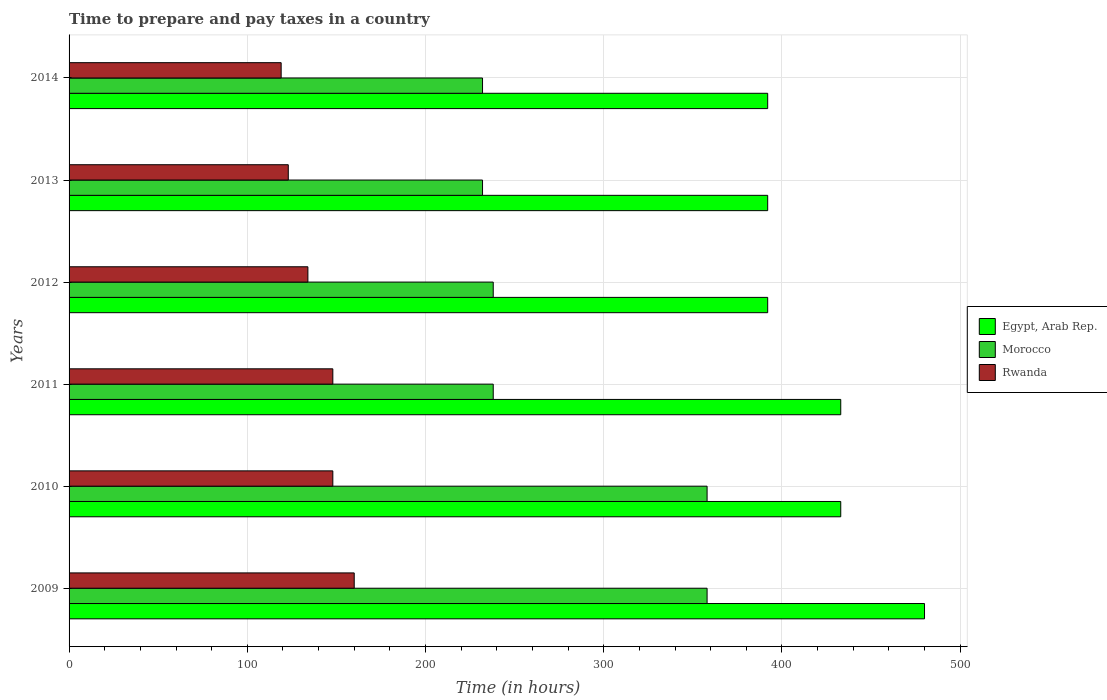How many different coloured bars are there?
Ensure brevity in your answer.  3. How many groups of bars are there?
Ensure brevity in your answer.  6. Are the number of bars per tick equal to the number of legend labels?
Your answer should be compact. Yes. How many bars are there on the 6th tick from the top?
Your answer should be compact. 3. How many bars are there on the 5th tick from the bottom?
Make the answer very short. 3. In how many cases, is the number of bars for a given year not equal to the number of legend labels?
Provide a succinct answer. 0. What is the number of hours required to prepare and pay taxes in Morocco in 2009?
Your response must be concise. 358. Across all years, what is the maximum number of hours required to prepare and pay taxes in Morocco?
Ensure brevity in your answer.  358. Across all years, what is the minimum number of hours required to prepare and pay taxes in Rwanda?
Offer a very short reply. 119. In which year was the number of hours required to prepare and pay taxes in Egypt, Arab Rep. maximum?
Your response must be concise. 2009. In which year was the number of hours required to prepare and pay taxes in Rwanda minimum?
Your answer should be compact. 2014. What is the total number of hours required to prepare and pay taxes in Rwanda in the graph?
Ensure brevity in your answer.  832. What is the difference between the number of hours required to prepare and pay taxes in Morocco in 2009 and that in 2013?
Provide a short and direct response. 126. What is the difference between the number of hours required to prepare and pay taxes in Morocco in 2009 and the number of hours required to prepare and pay taxes in Egypt, Arab Rep. in 2014?
Make the answer very short. -34. What is the average number of hours required to prepare and pay taxes in Morocco per year?
Your response must be concise. 276. In the year 2013, what is the difference between the number of hours required to prepare and pay taxes in Egypt, Arab Rep. and number of hours required to prepare and pay taxes in Rwanda?
Offer a terse response. 269. What is the ratio of the number of hours required to prepare and pay taxes in Egypt, Arab Rep. in 2011 to that in 2014?
Ensure brevity in your answer.  1.1. Is the number of hours required to prepare and pay taxes in Rwanda in 2013 less than that in 2014?
Ensure brevity in your answer.  No. Is the difference between the number of hours required to prepare and pay taxes in Egypt, Arab Rep. in 2009 and 2013 greater than the difference between the number of hours required to prepare and pay taxes in Rwanda in 2009 and 2013?
Make the answer very short. Yes. What is the difference between the highest and the lowest number of hours required to prepare and pay taxes in Egypt, Arab Rep.?
Your answer should be very brief. 88. What does the 2nd bar from the top in 2011 represents?
Your answer should be compact. Morocco. What does the 2nd bar from the bottom in 2011 represents?
Keep it short and to the point. Morocco. How many years are there in the graph?
Ensure brevity in your answer.  6. What is the difference between two consecutive major ticks on the X-axis?
Keep it short and to the point. 100. Are the values on the major ticks of X-axis written in scientific E-notation?
Give a very brief answer. No. Does the graph contain any zero values?
Your answer should be compact. No. Does the graph contain grids?
Provide a succinct answer. Yes. How are the legend labels stacked?
Ensure brevity in your answer.  Vertical. What is the title of the graph?
Provide a short and direct response. Time to prepare and pay taxes in a country. Does "Macedonia" appear as one of the legend labels in the graph?
Ensure brevity in your answer.  No. What is the label or title of the X-axis?
Keep it short and to the point. Time (in hours). What is the Time (in hours) of Egypt, Arab Rep. in 2009?
Provide a succinct answer. 480. What is the Time (in hours) in Morocco in 2009?
Your answer should be very brief. 358. What is the Time (in hours) of Rwanda in 2009?
Your answer should be compact. 160. What is the Time (in hours) in Egypt, Arab Rep. in 2010?
Provide a short and direct response. 433. What is the Time (in hours) of Morocco in 2010?
Your answer should be very brief. 358. What is the Time (in hours) of Rwanda in 2010?
Offer a very short reply. 148. What is the Time (in hours) in Egypt, Arab Rep. in 2011?
Your answer should be compact. 433. What is the Time (in hours) in Morocco in 2011?
Your response must be concise. 238. What is the Time (in hours) of Rwanda in 2011?
Give a very brief answer. 148. What is the Time (in hours) of Egypt, Arab Rep. in 2012?
Provide a succinct answer. 392. What is the Time (in hours) of Morocco in 2012?
Your answer should be very brief. 238. What is the Time (in hours) of Rwanda in 2012?
Provide a succinct answer. 134. What is the Time (in hours) in Egypt, Arab Rep. in 2013?
Your response must be concise. 392. What is the Time (in hours) of Morocco in 2013?
Provide a short and direct response. 232. What is the Time (in hours) in Rwanda in 2013?
Keep it short and to the point. 123. What is the Time (in hours) in Egypt, Arab Rep. in 2014?
Give a very brief answer. 392. What is the Time (in hours) of Morocco in 2014?
Your response must be concise. 232. What is the Time (in hours) in Rwanda in 2014?
Ensure brevity in your answer.  119. Across all years, what is the maximum Time (in hours) in Egypt, Arab Rep.?
Offer a terse response. 480. Across all years, what is the maximum Time (in hours) of Morocco?
Provide a succinct answer. 358. Across all years, what is the maximum Time (in hours) in Rwanda?
Provide a short and direct response. 160. Across all years, what is the minimum Time (in hours) in Egypt, Arab Rep.?
Offer a very short reply. 392. Across all years, what is the minimum Time (in hours) of Morocco?
Make the answer very short. 232. Across all years, what is the minimum Time (in hours) in Rwanda?
Make the answer very short. 119. What is the total Time (in hours) of Egypt, Arab Rep. in the graph?
Provide a succinct answer. 2522. What is the total Time (in hours) of Morocco in the graph?
Provide a succinct answer. 1656. What is the total Time (in hours) in Rwanda in the graph?
Ensure brevity in your answer.  832. What is the difference between the Time (in hours) of Egypt, Arab Rep. in 2009 and that in 2010?
Provide a short and direct response. 47. What is the difference between the Time (in hours) in Morocco in 2009 and that in 2010?
Your answer should be compact. 0. What is the difference between the Time (in hours) of Morocco in 2009 and that in 2011?
Provide a succinct answer. 120. What is the difference between the Time (in hours) in Rwanda in 2009 and that in 2011?
Your response must be concise. 12. What is the difference between the Time (in hours) in Egypt, Arab Rep. in 2009 and that in 2012?
Offer a very short reply. 88. What is the difference between the Time (in hours) in Morocco in 2009 and that in 2012?
Offer a terse response. 120. What is the difference between the Time (in hours) of Rwanda in 2009 and that in 2012?
Your answer should be compact. 26. What is the difference between the Time (in hours) of Egypt, Arab Rep. in 2009 and that in 2013?
Offer a terse response. 88. What is the difference between the Time (in hours) in Morocco in 2009 and that in 2013?
Your response must be concise. 126. What is the difference between the Time (in hours) in Rwanda in 2009 and that in 2013?
Offer a terse response. 37. What is the difference between the Time (in hours) in Egypt, Arab Rep. in 2009 and that in 2014?
Your answer should be very brief. 88. What is the difference between the Time (in hours) in Morocco in 2009 and that in 2014?
Make the answer very short. 126. What is the difference between the Time (in hours) of Rwanda in 2009 and that in 2014?
Your response must be concise. 41. What is the difference between the Time (in hours) in Morocco in 2010 and that in 2011?
Provide a succinct answer. 120. What is the difference between the Time (in hours) in Rwanda in 2010 and that in 2011?
Give a very brief answer. 0. What is the difference between the Time (in hours) of Egypt, Arab Rep. in 2010 and that in 2012?
Make the answer very short. 41. What is the difference between the Time (in hours) of Morocco in 2010 and that in 2012?
Give a very brief answer. 120. What is the difference between the Time (in hours) of Rwanda in 2010 and that in 2012?
Give a very brief answer. 14. What is the difference between the Time (in hours) in Egypt, Arab Rep. in 2010 and that in 2013?
Ensure brevity in your answer.  41. What is the difference between the Time (in hours) in Morocco in 2010 and that in 2013?
Your answer should be compact. 126. What is the difference between the Time (in hours) in Egypt, Arab Rep. in 2010 and that in 2014?
Your response must be concise. 41. What is the difference between the Time (in hours) of Morocco in 2010 and that in 2014?
Ensure brevity in your answer.  126. What is the difference between the Time (in hours) in Morocco in 2011 and that in 2012?
Provide a succinct answer. 0. What is the difference between the Time (in hours) in Egypt, Arab Rep. in 2011 and that in 2013?
Provide a short and direct response. 41. What is the difference between the Time (in hours) in Rwanda in 2011 and that in 2013?
Keep it short and to the point. 25. What is the difference between the Time (in hours) in Egypt, Arab Rep. in 2011 and that in 2014?
Offer a terse response. 41. What is the difference between the Time (in hours) in Egypt, Arab Rep. in 2012 and that in 2013?
Provide a short and direct response. 0. What is the difference between the Time (in hours) in Rwanda in 2012 and that in 2013?
Your answer should be very brief. 11. What is the difference between the Time (in hours) in Morocco in 2012 and that in 2014?
Ensure brevity in your answer.  6. What is the difference between the Time (in hours) of Rwanda in 2012 and that in 2014?
Ensure brevity in your answer.  15. What is the difference between the Time (in hours) of Morocco in 2013 and that in 2014?
Offer a very short reply. 0. What is the difference between the Time (in hours) in Rwanda in 2013 and that in 2014?
Give a very brief answer. 4. What is the difference between the Time (in hours) of Egypt, Arab Rep. in 2009 and the Time (in hours) of Morocco in 2010?
Offer a terse response. 122. What is the difference between the Time (in hours) of Egypt, Arab Rep. in 2009 and the Time (in hours) of Rwanda in 2010?
Your answer should be very brief. 332. What is the difference between the Time (in hours) of Morocco in 2009 and the Time (in hours) of Rwanda in 2010?
Keep it short and to the point. 210. What is the difference between the Time (in hours) in Egypt, Arab Rep. in 2009 and the Time (in hours) in Morocco in 2011?
Keep it short and to the point. 242. What is the difference between the Time (in hours) in Egypt, Arab Rep. in 2009 and the Time (in hours) in Rwanda in 2011?
Ensure brevity in your answer.  332. What is the difference between the Time (in hours) of Morocco in 2009 and the Time (in hours) of Rwanda in 2011?
Make the answer very short. 210. What is the difference between the Time (in hours) of Egypt, Arab Rep. in 2009 and the Time (in hours) of Morocco in 2012?
Offer a very short reply. 242. What is the difference between the Time (in hours) in Egypt, Arab Rep. in 2009 and the Time (in hours) in Rwanda in 2012?
Provide a succinct answer. 346. What is the difference between the Time (in hours) of Morocco in 2009 and the Time (in hours) of Rwanda in 2012?
Keep it short and to the point. 224. What is the difference between the Time (in hours) in Egypt, Arab Rep. in 2009 and the Time (in hours) in Morocco in 2013?
Ensure brevity in your answer.  248. What is the difference between the Time (in hours) in Egypt, Arab Rep. in 2009 and the Time (in hours) in Rwanda in 2013?
Your answer should be very brief. 357. What is the difference between the Time (in hours) of Morocco in 2009 and the Time (in hours) of Rwanda in 2013?
Ensure brevity in your answer.  235. What is the difference between the Time (in hours) in Egypt, Arab Rep. in 2009 and the Time (in hours) in Morocco in 2014?
Ensure brevity in your answer.  248. What is the difference between the Time (in hours) in Egypt, Arab Rep. in 2009 and the Time (in hours) in Rwanda in 2014?
Your response must be concise. 361. What is the difference between the Time (in hours) in Morocco in 2009 and the Time (in hours) in Rwanda in 2014?
Keep it short and to the point. 239. What is the difference between the Time (in hours) in Egypt, Arab Rep. in 2010 and the Time (in hours) in Morocco in 2011?
Offer a terse response. 195. What is the difference between the Time (in hours) in Egypt, Arab Rep. in 2010 and the Time (in hours) in Rwanda in 2011?
Your response must be concise. 285. What is the difference between the Time (in hours) in Morocco in 2010 and the Time (in hours) in Rwanda in 2011?
Your answer should be very brief. 210. What is the difference between the Time (in hours) of Egypt, Arab Rep. in 2010 and the Time (in hours) of Morocco in 2012?
Keep it short and to the point. 195. What is the difference between the Time (in hours) of Egypt, Arab Rep. in 2010 and the Time (in hours) of Rwanda in 2012?
Keep it short and to the point. 299. What is the difference between the Time (in hours) in Morocco in 2010 and the Time (in hours) in Rwanda in 2012?
Give a very brief answer. 224. What is the difference between the Time (in hours) of Egypt, Arab Rep. in 2010 and the Time (in hours) of Morocco in 2013?
Your response must be concise. 201. What is the difference between the Time (in hours) of Egypt, Arab Rep. in 2010 and the Time (in hours) of Rwanda in 2013?
Offer a very short reply. 310. What is the difference between the Time (in hours) in Morocco in 2010 and the Time (in hours) in Rwanda in 2013?
Provide a short and direct response. 235. What is the difference between the Time (in hours) in Egypt, Arab Rep. in 2010 and the Time (in hours) in Morocco in 2014?
Your response must be concise. 201. What is the difference between the Time (in hours) of Egypt, Arab Rep. in 2010 and the Time (in hours) of Rwanda in 2014?
Make the answer very short. 314. What is the difference between the Time (in hours) of Morocco in 2010 and the Time (in hours) of Rwanda in 2014?
Ensure brevity in your answer.  239. What is the difference between the Time (in hours) of Egypt, Arab Rep. in 2011 and the Time (in hours) of Morocco in 2012?
Your answer should be very brief. 195. What is the difference between the Time (in hours) of Egypt, Arab Rep. in 2011 and the Time (in hours) of Rwanda in 2012?
Offer a very short reply. 299. What is the difference between the Time (in hours) in Morocco in 2011 and the Time (in hours) in Rwanda in 2012?
Provide a succinct answer. 104. What is the difference between the Time (in hours) of Egypt, Arab Rep. in 2011 and the Time (in hours) of Morocco in 2013?
Provide a succinct answer. 201. What is the difference between the Time (in hours) in Egypt, Arab Rep. in 2011 and the Time (in hours) in Rwanda in 2013?
Offer a terse response. 310. What is the difference between the Time (in hours) of Morocco in 2011 and the Time (in hours) of Rwanda in 2013?
Keep it short and to the point. 115. What is the difference between the Time (in hours) in Egypt, Arab Rep. in 2011 and the Time (in hours) in Morocco in 2014?
Make the answer very short. 201. What is the difference between the Time (in hours) in Egypt, Arab Rep. in 2011 and the Time (in hours) in Rwanda in 2014?
Your answer should be very brief. 314. What is the difference between the Time (in hours) of Morocco in 2011 and the Time (in hours) of Rwanda in 2014?
Your answer should be very brief. 119. What is the difference between the Time (in hours) in Egypt, Arab Rep. in 2012 and the Time (in hours) in Morocco in 2013?
Offer a very short reply. 160. What is the difference between the Time (in hours) in Egypt, Arab Rep. in 2012 and the Time (in hours) in Rwanda in 2013?
Make the answer very short. 269. What is the difference between the Time (in hours) in Morocco in 2012 and the Time (in hours) in Rwanda in 2013?
Ensure brevity in your answer.  115. What is the difference between the Time (in hours) in Egypt, Arab Rep. in 2012 and the Time (in hours) in Morocco in 2014?
Ensure brevity in your answer.  160. What is the difference between the Time (in hours) in Egypt, Arab Rep. in 2012 and the Time (in hours) in Rwanda in 2014?
Provide a succinct answer. 273. What is the difference between the Time (in hours) of Morocco in 2012 and the Time (in hours) of Rwanda in 2014?
Offer a very short reply. 119. What is the difference between the Time (in hours) of Egypt, Arab Rep. in 2013 and the Time (in hours) of Morocco in 2014?
Your answer should be very brief. 160. What is the difference between the Time (in hours) in Egypt, Arab Rep. in 2013 and the Time (in hours) in Rwanda in 2014?
Offer a terse response. 273. What is the difference between the Time (in hours) of Morocco in 2013 and the Time (in hours) of Rwanda in 2014?
Offer a very short reply. 113. What is the average Time (in hours) of Egypt, Arab Rep. per year?
Offer a very short reply. 420.33. What is the average Time (in hours) of Morocco per year?
Give a very brief answer. 276. What is the average Time (in hours) of Rwanda per year?
Make the answer very short. 138.67. In the year 2009, what is the difference between the Time (in hours) of Egypt, Arab Rep. and Time (in hours) of Morocco?
Your answer should be compact. 122. In the year 2009, what is the difference between the Time (in hours) of Egypt, Arab Rep. and Time (in hours) of Rwanda?
Your answer should be compact. 320. In the year 2009, what is the difference between the Time (in hours) of Morocco and Time (in hours) of Rwanda?
Provide a succinct answer. 198. In the year 2010, what is the difference between the Time (in hours) of Egypt, Arab Rep. and Time (in hours) of Rwanda?
Give a very brief answer. 285. In the year 2010, what is the difference between the Time (in hours) in Morocco and Time (in hours) in Rwanda?
Make the answer very short. 210. In the year 2011, what is the difference between the Time (in hours) in Egypt, Arab Rep. and Time (in hours) in Morocco?
Your answer should be compact. 195. In the year 2011, what is the difference between the Time (in hours) in Egypt, Arab Rep. and Time (in hours) in Rwanda?
Your answer should be compact. 285. In the year 2011, what is the difference between the Time (in hours) of Morocco and Time (in hours) of Rwanda?
Give a very brief answer. 90. In the year 2012, what is the difference between the Time (in hours) in Egypt, Arab Rep. and Time (in hours) in Morocco?
Offer a very short reply. 154. In the year 2012, what is the difference between the Time (in hours) of Egypt, Arab Rep. and Time (in hours) of Rwanda?
Offer a very short reply. 258. In the year 2012, what is the difference between the Time (in hours) of Morocco and Time (in hours) of Rwanda?
Give a very brief answer. 104. In the year 2013, what is the difference between the Time (in hours) in Egypt, Arab Rep. and Time (in hours) in Morocco?
Your response must be concise. 160. In the year 2013, what is the difference between the Time (in hours) of Egypt, Arab Rep. and Time (in hours) of Rwanda?
Make the answer very short. 269. In the year 2013, what is the difference between the Time (in hours) in Morocco and Time (in hours) in Rwanda?
Make the answer very short. 109. In the year 2014, what is the difference between the Time (in hours) in Egypt, Arab Rep. and Time (in hours) in Morocco?
Provide a succinct answer. 160. In the year 2014, what is the difference between the Time (in hours) in Egypt, Arab Rep. and Time (in hours) in Rwanda?
Your answer should be compact. 273. In the year 2014, what is the difference between the Time (in hours) in Morocco and Time (in hours) in Rwanda?
Offer a terse response. 113. What is the ratio of the Time (in hours) of Egypt, Arab Rep. in 2009 to that in 2010?
Your answer should be very brief. 1.11. What is the ratio of the Time (in hours) of Morocco in 2009 to that in 2010?
Give a very brief answer. 1. What is the ratio of the Time (in hours) in Rwanda in 2009 to that in 2010?
Your answer should be very brief. 1.08. What is the ratio of the Time (in hours) in Egypt, Arab Rep. in 2009 to that in 2011?
Your answer should be compact. 1.11. What is the ratio of the Time (in hours) of Morocco in 2009 to that in 2011?
Keep it short and to the point. 1.5. What is the ratio of the Time (in hours) in Rwanda in 2009 to that in 2011?
Make the answer very short. 1.08. What is the ratio of the Time (in hours) of Egypt, Arab Rep. in 2009 to that in 2012?
Your answer should be very brief. 1.22. What is the ratio of the Time (in hours) in Morocco in 2009 to that in 2012?
Offer a very short reply. 1.5. What is the ratio of the Time (in hours) of Rwanda in 2009 to that in 2012?
Your answer should be compact. 1.19. What is the ratio of the Time (in hours) of Egypt, Arab Rep. in 2009 to that in 2013?
Your response must be concise. 1.22. What is the ratio of the Time (in hours) of Morocco in 2009 to that in 2013?
Provide a succinct answer. 1.54. What is the ratio of the Time (in hours) in Rwanda in 2009 to that in 2013?
Your answer should be compact. 1.3. What is the ratio of the Time (in hours) in Egypt, Arab Rep. in 2009 to that in 2014?
Offer a terse response. 1.22. What is the ratio of the Time (in hours) in Morocco in 2009 to that in 2014?
Keep it short and to the point. 1.54. What is the ratio of the Time (in hours) of Rwanda in 2009 to that in 2014?
Give a very brief answer. 1.34. What is the ratio of the Time (in hours) in Egypt, Arab Rep. in 2010 to that in 2011?
Provide a succinct answer. 1. What is the ratio of the Time (in hours) of Morocco in 2010 to that in 2011?
Your answer should be compact. 1.5. What is the ratio of the Time (in hours) in Rwanda in 2010 to that in 2011?
Offer a terse response. 1. What is the ratio of the Time (in hours) of Egypt, Arab Rep. in 2010 to that in 2012?
Your response must be concise. 1.1. What is the ratio of the Time (in hours) in Morocco in 2010 to that in 2012?
Make the answer very short. 1.5. What is the ratio of the Time (in hours) in Rwanda in 2010 to that in 2012?
Your response must be concise. 1.1. What is the ratio of the Time (in hours) in Egypt, Arab Rep. in 2010 to that in 2013?
Provide a short and direct response. 1.1. What is the ratio of the Time (in hours) in Morocco in 2010 to that in 2013?
Give a very brief answer. 1.54. What is the ratio of the Time (in hours) in Rwanda in 2010 to that in 2013?
Provide a short and direct response. 1.2. What is the ratio of the Time (in hours) of Egypt, Arab Rep. in 2010 to that in 2014?
Offer a very short reply. 1.1. What is the ratio of the Time (in hours) in Morocco in 2010 to that in 2014?
Provide a short and direct response. 1.54. What is the ratio of the Time (in hours) in Rwanda in 2010 to that in 2014?
Keep it short and to the point. 1.24. What is the ratio of the Time (in hours) in Egypt, Arab Rep. in 2011 to that in 2012?
Provide a short and direct response. 1.1. What is the ratio of the Time (in hours) in Rwanda in 2011 to that in 2012?
Your answer should be compact. 1.1. What is the ratio of the Time (in hours) of Egypt, Arab Rep. in 2011 to that in 2013?
Give a very brief answer. 1.1. What is the ratio of the Time (in hours) in Morocco in 2011 to that in 2013?
Offer a terse response. 1.03. What is the ratio of the Time (in hours) of Rwanda in 2011 to that in 2013?
Provide a succinct answer. 1.2. What is the ratio of the Time (in hours) in Egypt, Arab Rep. in 2011 to that in 2014?
Provide a succinct answer. 1.1. What is the ratio of the Time (in hours) in Morocco in 2011 to that in 2014?
Give a very brief answer. 1.03. What is the ratio of the Time (in hours) in Rwanda in 2011 to that in 2014?
Provide a succinct answer. 1.24. What is the ratio of the Time (in hours) in Egypt, Arab Rep. in 2012 to that in 2013?
Your answer should be compact. 1. What is the ratio of the Time (in hours) of Morocco in 2012 to that in 2013?
Provide a succinct answer. 1.03. What is the ratio of the Time (in hours) in Rwanda in 2012 to that in 2013?
Provide a short and direct response. 1.09. What is the ratio of the Time (in hours) of Egypt, Arab Rep. in 2012 to that in 2014?
Your response must be concise. 1. What is the ratio of the Time (in hours) of Morocco in 2012 to that in 2014?
Offer a very short reply. 1.03. What is the ratio of the Time (in hours) of Rwanda in 2012 to that in 2014?
Provide a succinct answer. 1.13. What is the ratio of the Time (in hours) of Egypt, Arab Rep. in 2013 to that in 2014?
Provide a short and direct response. 1. What is the ratio of the Time (in hours) in Morocco in 2013 to that in 2014?
Your answer should be very brief. 1. What is the ratio of the Time (in hours) in Rwanda in 2013 to that in 2014?
Offer a terse response. 1.03. What is the difference between the highest and the second highest Time (in hours) of Morocco?
Your response must be concise. 0. What is the difference between the highest and the second highest Time (in hours) of Rwanda?
Your answer should be very brief. 12. What is the difference between the highest and the lowest Time (in hours) in Egypt, Arab Rep.?
Make the answer very short. 88. What is the difference between the highest and the lowest Time (in hours) in Morocco?
Offer a very short reply. 126. 